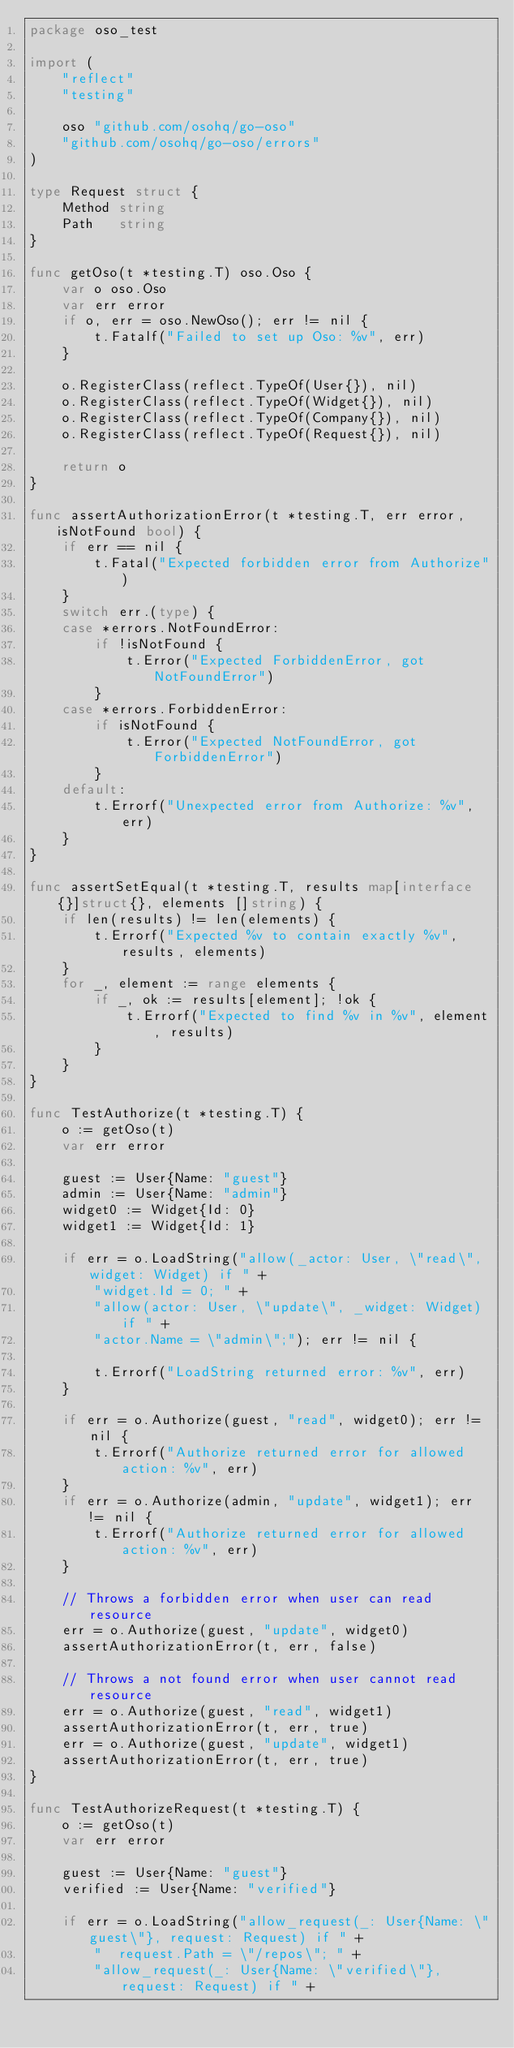<code> <loc_0><loc_0><loc_500><loc_500><_Go_>package oso_test

import (
	"reflect"
	"testing"

	oso "github.com/osohq/go-oso"
	"github.com/osohq/go-oso/errors"
)

type Request struct {
	Method string
	Path   string
}

func getOso(t *testing.T) oso.Oso {
	var o oso.Oso
	var err error
	if o, err = oso.NewOso(); err != nil {
		t.Fatalf("Failed to set up Oso: %v", err)
	}

	o.RegisterClass(reflect.TypeOf(User{}), nil)
	o.RegisterClass(reflect.TypeOf(Widget{}), nil)
	o.RegisterClass(reflect.TypeOf(Company{}), nil)
	o.RegisterClass(reflect.TypeOf(Request{}), nil)

	return o
}

func assertAuthorizationError(t *testing.T, err error, isNotFound bool) {
	if err == nil {
		t.Fatal("Expected forbidden error from Authorize")
	}
	switch err.(type) {
	case *errors.NotFoundError:
		if !isNotFound {
			t.Error("Expected ForbiddenError, got NotFoundError")
		}
	case *errors.ForbiddenError:
		if isNotFound {
			t.Error("Expected NotFoundError, got ForbiddenError")
		}
	default:
		t.Errorf("Unexpected error from Authorize: %v", err)
	}
}

func assertSetEqual(t *testing.T, results map[interface{}]struct{}, elements []string) {
	if len(results) != len(elements) {
		t.Errorf("Expected %v to contain exactly %v", results, elements)
	}
	for _, element := range elements {
		if _, ok := results[element]; !ok {
			t.Errorf("Expected to find %v in %v", element, results)
		}
	}
}

func TestAuthorize(t *testing.T) {
	o := getOso(t)
	var err error

	guest := User{Name: "guest"}
	admin := User{Name: "admin"}
	widget0 := Widget{Id: 0}
	widget1 := Widget{Id: 1}

	if err = o.LoadString("allow(_actor: User, \"read\", widget: Widget) if " +
		"widget.Id = 0; " +
		"allow(actor: User, \"update\", _widget: Widget) if " +
		"actor.Name = \"admin\";"); err != nil {

		t.Errorf("LoadString returned error: %v", err)
	}

	if err = o.Authorize(guest, "read", widget0); err != nil {
		t.Errorf("Authorize returned error for allowed action: %v", err)
	}
	if err = o.Authorize(admin, "update", widget1); err != nil {
		t.Errorf("Authorize returned error for allowed action: %v", err)
	}

	// Throws a forbidden error when user can read resource
	err = o.Authorize(guest, "update", widget0)
	assertAuthorizationError(t, err, false)

	// Throws a not found error when user cannot read resource
	err = o.Authorize(guest, "read", widget1)
	assertAuthorizationError(t, err, true)
	err = o.Authorize(guest, "update", widget1)
	assertAuthorizationError(t, err, true)
}

func TestAuthorizeRequest(t *testing.T) {
	o := getOso(t)
	var err error

	guest := User{Name: "guest"}
	verified := User{Name: "verified"}

	if err = o.LoadString("allow_request(_: User{Name: \"guest\"}, request: Request) if " +
		"  request.Path = \"/repos\"; " +
		"allow_request(_: User{Name: \"verified\"}, request: Request) if " +</code> 